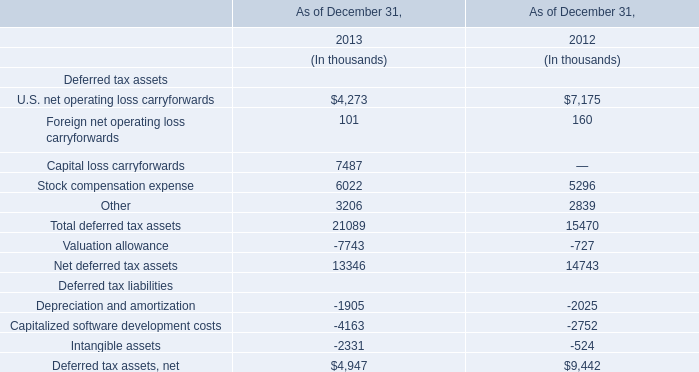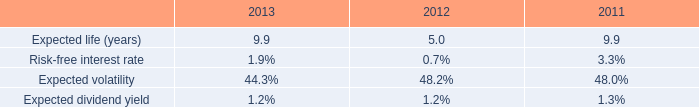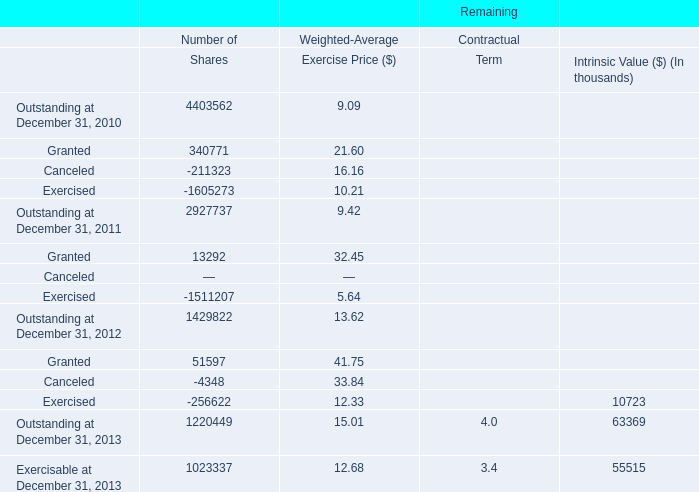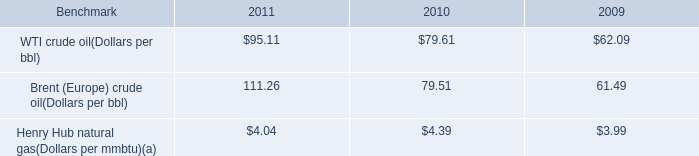What's the average of Granted and Outstanding at December 31, 2011 in Shares? 
Computations: ((340771 + 2927737) / 2)
Answer: 1634254.0. 